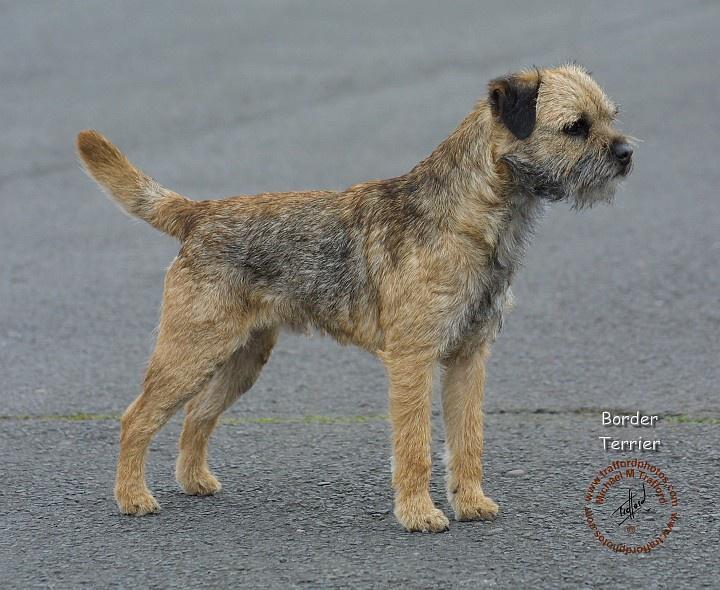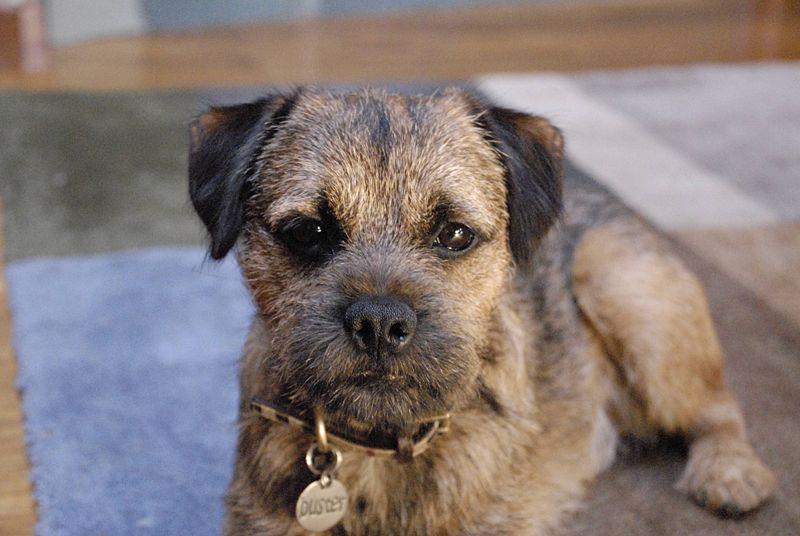The first image is the image on the left, the second image is the image on the right. Considering the images on both sides, is "Dog are shown with a dead animal in at least one of the images." valid? Answer yes or no. No. The first image is the image on the left, the second image is the image on the right. For the images shown, is this caption "There are at least two animals in the image on the right." true? Answer yes or no. No. 